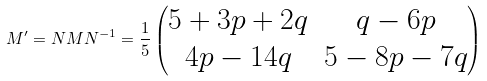<formula> <loc_0><loc_0><loc_500><loc_500>M ^ { \prime } = N M N ^ { - 1 } = \frac { 1 } { 5 } \begin{pmatrix} 5 + 3 p + 2 q & q - 6 p \\ 4 p - 1 4 q & 5 - 8 p - 7 q \end{pmatrix}</formula> 